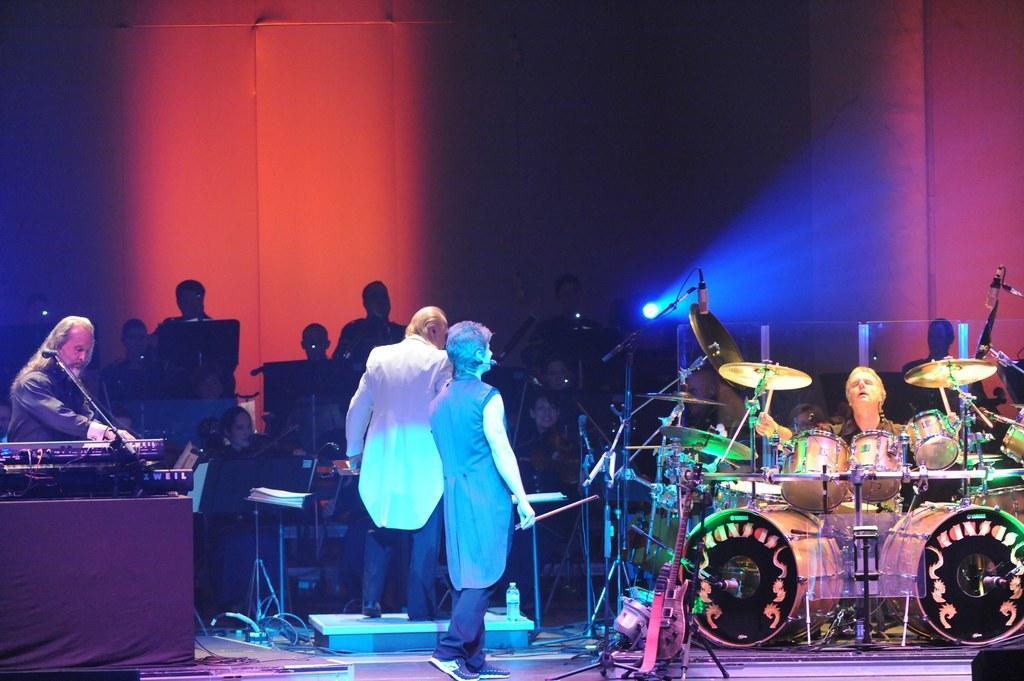In one or two sentences, can you explain what this image depicts? In this image I can see the group of people and these people are playing the musical instruments. 